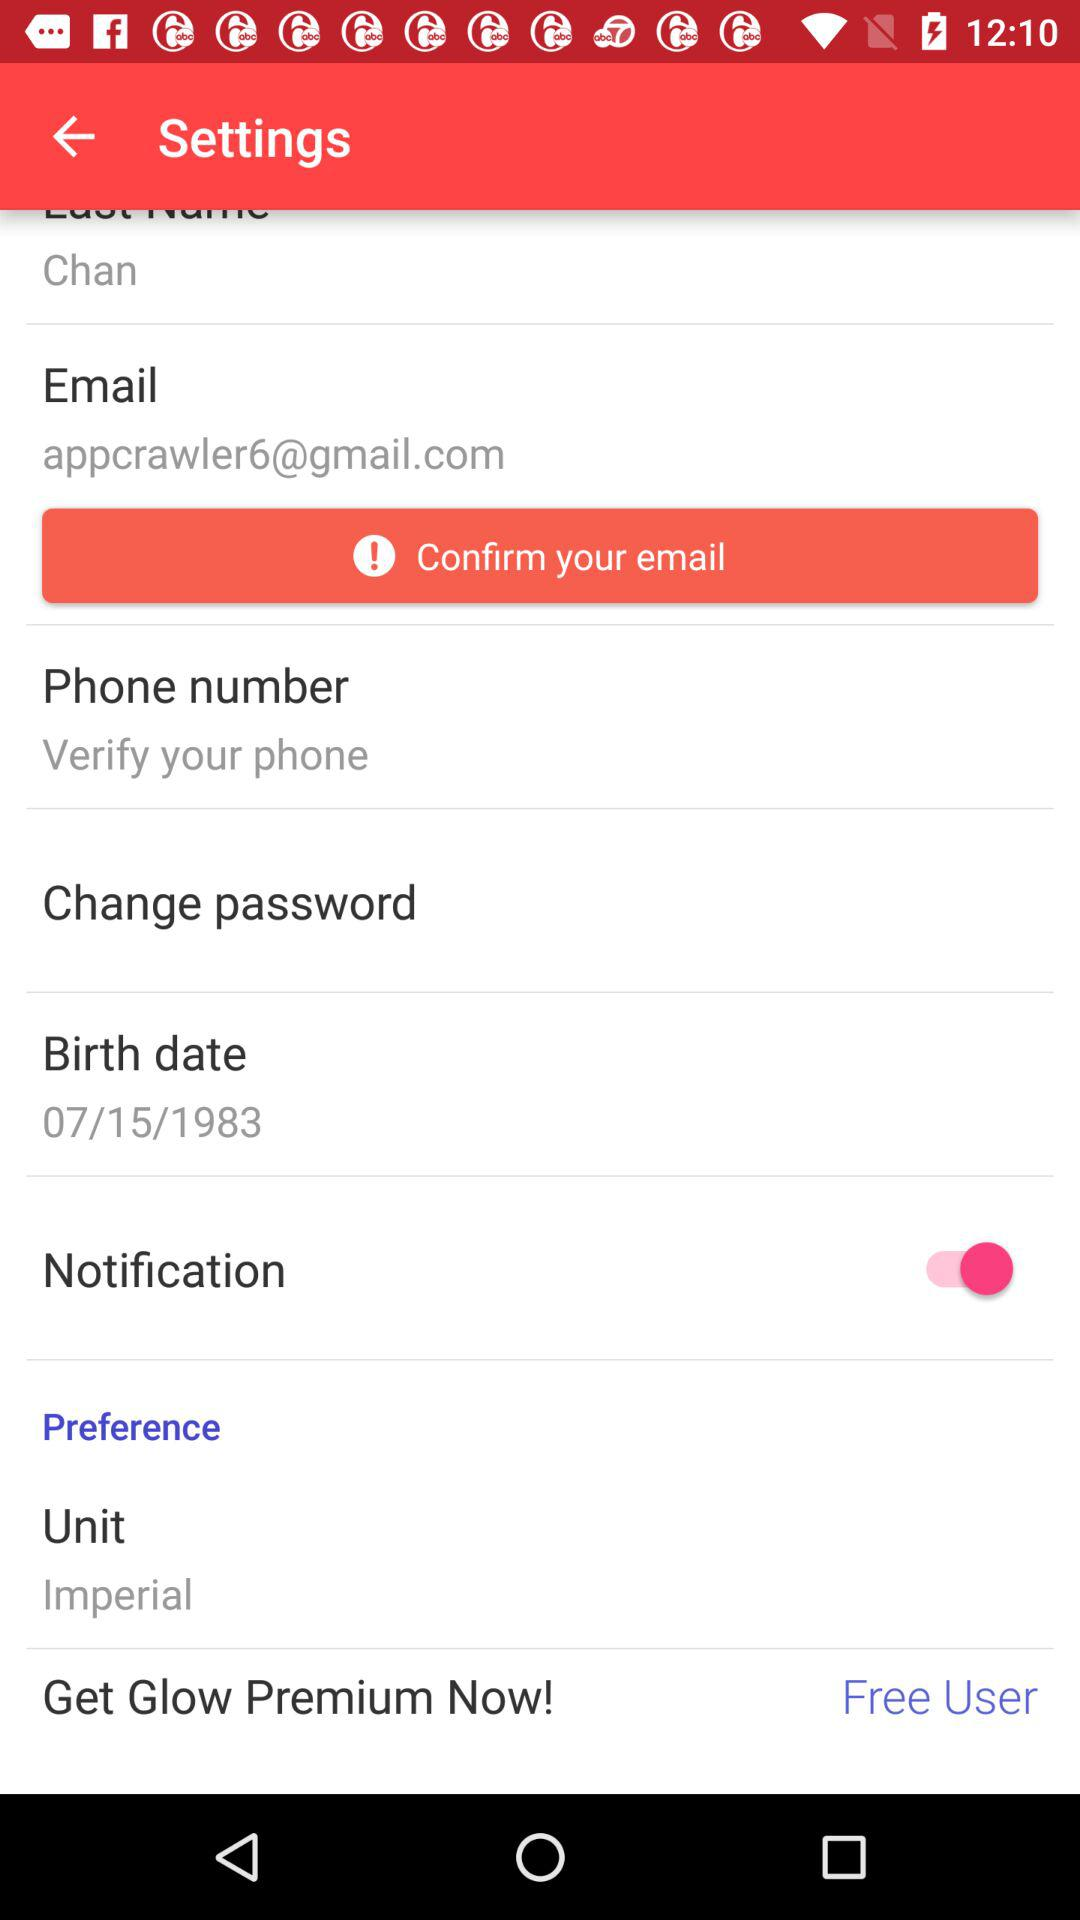What unit is displayed? The displayed unit is "Imperial". 